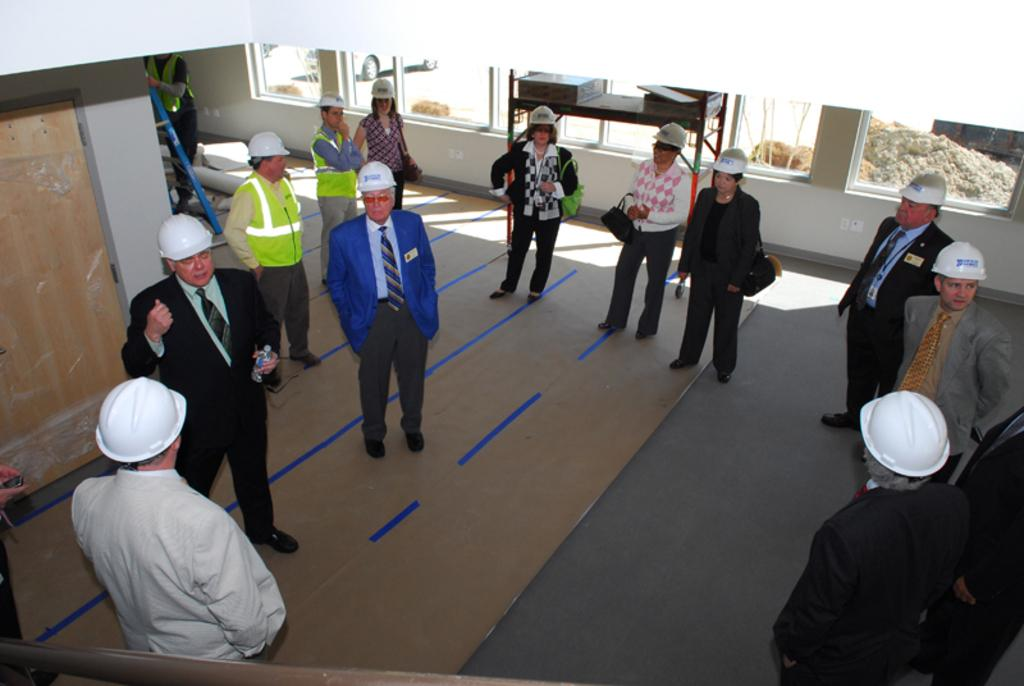What are the people in the image doing? The persons standing on the floor are likely engaged in some activity or standing in a particular location. What architectural features can be seen in the image? There is a door, a wall, and windows visible in the image. What type of furniture is present in the image? There is a table in the image. What can be seen through one of the windows? A vehicle is visible through one of the windows. What type of bucket is being used to treat the disease in the image? There is no bucket or disease present in the image. How many toes can be seen on the persons standing on the floor? The number of toes cannot be determined from the image, as feet are not visible. 